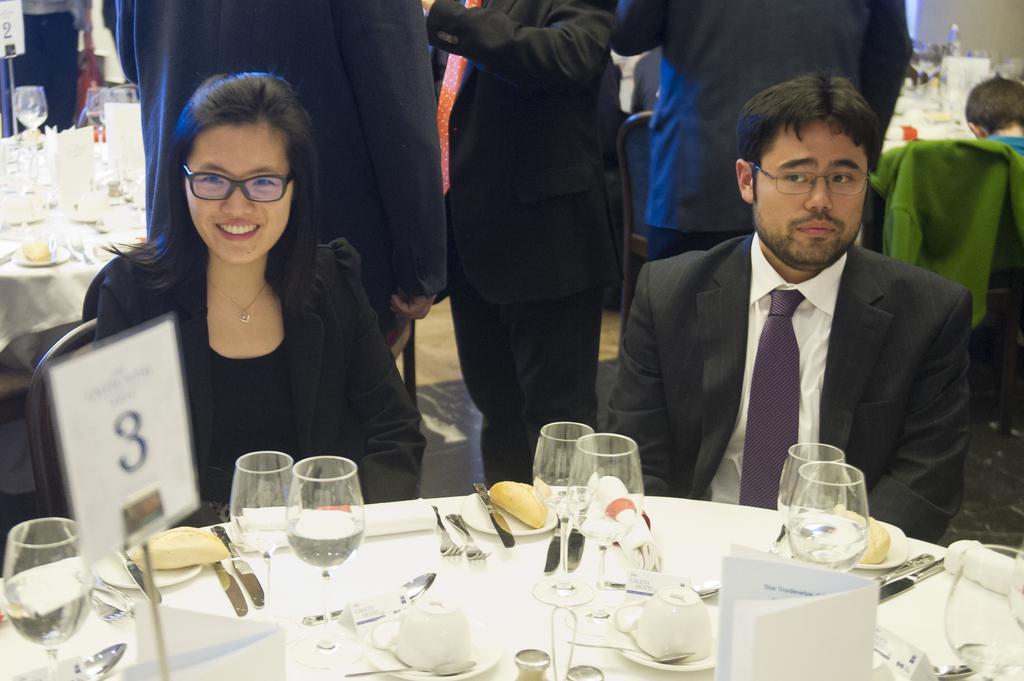Could you give a brief overview of what you see in this image? In this Picture we can see the a man wearing black coat is sitting on the chair and in front a dining table on which some glasses, knife , forks and clothes. Beside we can see a another woman wearing black coat and specs is smiling towards the camera. Behind we can see three man wearing black coat is standing and other tables can be seen. 